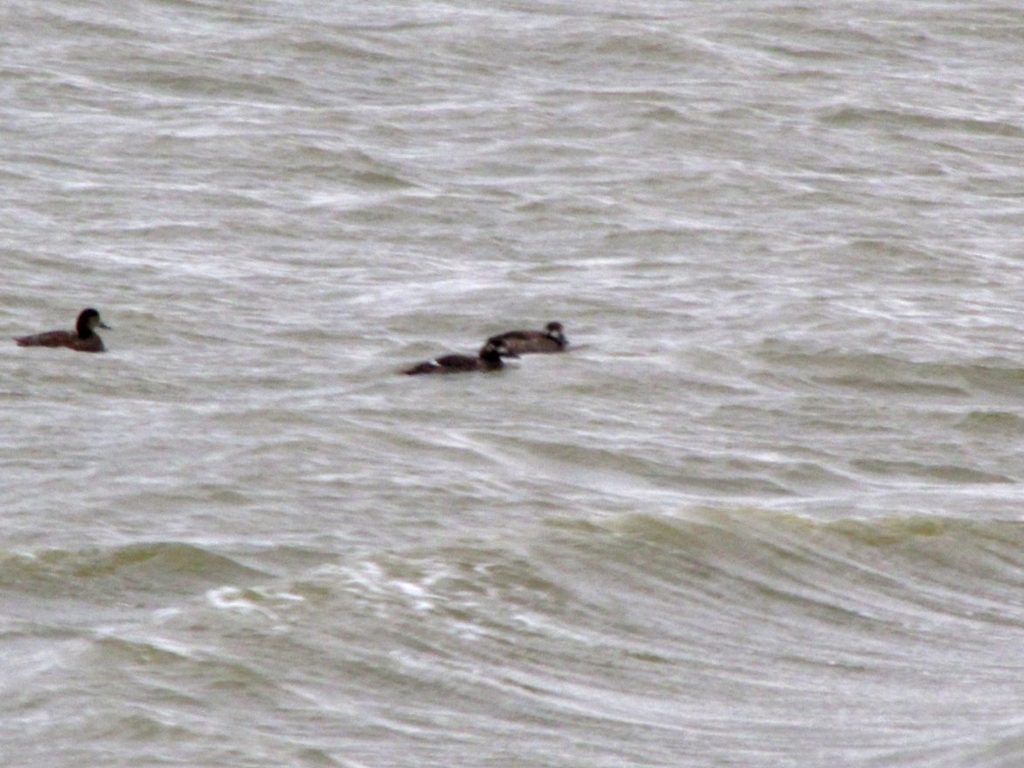Can you describe what's happening in this image? In this image, a group of ducks is spotted swimming in a body of water with noticeable ripples, likely caused by the wind. The image captures a natural and common behavior of these birds in their aquatic habitat. What can you tell me about the habitat of these ducks? Ducks are adaptable birds found in a wide range of aquatic environments, such as lakes, rivers, and coastal waters. This specific habitat appears to be a large, open body of water, which provides the ducks with resources for feeding, breeding, and protection from predators. 